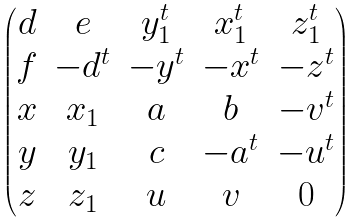Convert formula to latex. <formula><loc_0><loc_0><loc_500><loc_500>\begin{pmatrix} d & e & y _ { 1 } ^ { t } & x _ { 1 } ^ { t } & z _ { 1 } ^ { t } \\ f & - d ^ { t } & - y ^ { t } & - x ^ { t } & - z ^ { t } \\ x & x _ { 1 } & a & b & - v ^ { t } \\ y & y _ { 1 } & c & - a ^ { t } & - u ^ { t } \\ z & z _ { 1 } & u & v & 0 \end{pmatrix}</formula> 